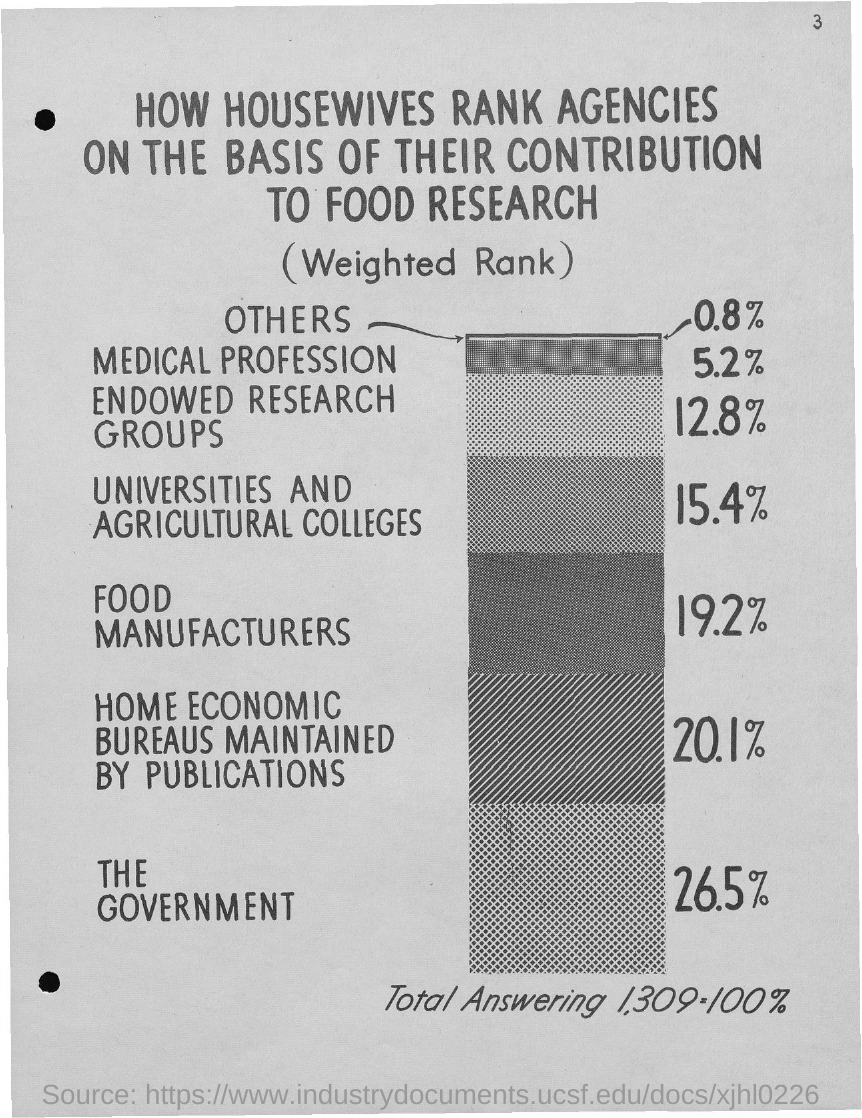Specify some key components in this picture. The government agency is ranked first in terms of its contributions to food research. The agency that contributes the least to food research is ranked lowest among others. This document's title is 'What is the title of the document? How housewives rank agencies on the basis of their contribution to food research..' The page number is 3. The second most influential agency in food research is the Home Economics Bureau, which is maintained by its numerous publications. 